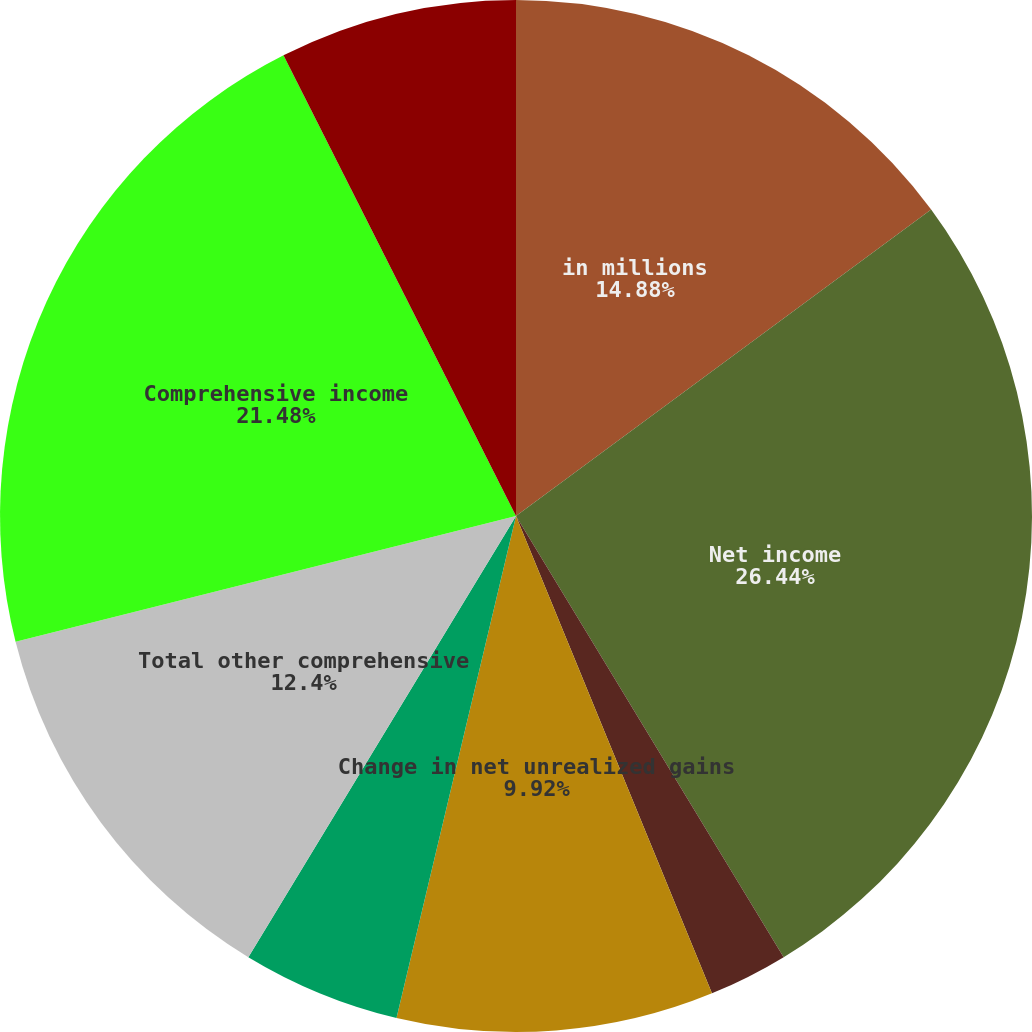Convert chart. <chart><loc_0><loc_0><loc_500><loc_500><pie_chart><fcel>in millions<fcel>Net income<fcel>Foreign currency translation<fcel>Change in net unrealized gains<fcel>Pension postretirement and<fcel>Total other comprehensive<fcel>Comprehensive income<fcel>Net income applicable to<fcel>Other comprehensive income<nl><fcel>14.88%<fcel>26.44%<fcel>2.48%<fcel>9.92%<fcel>4.96%<fcel>12.4%<fcel>21.48%<fcel>7.44%<fcel>0.0%<nl></chart> 